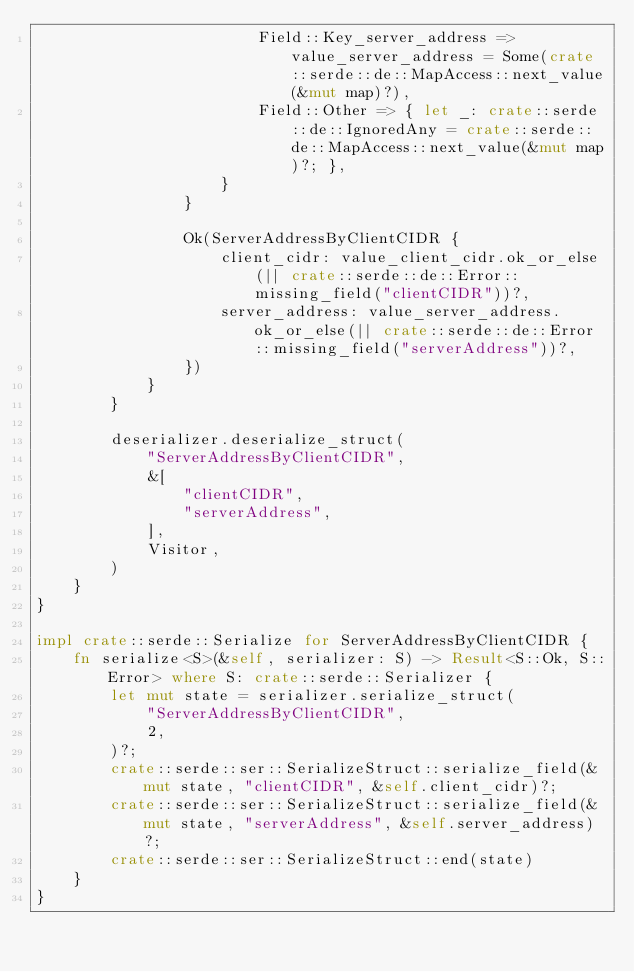Convert code to text. <code><loc_0><loc_0><loc_500><loc_500><_Rust_>                        Field::Key_server_address => value_server_address = Some(crate::serde::de::MapAccess::next_value(&mut map)?),
                        Field::Other => { let _: crate::serde::de::IgnoredAny = crate::serde::de::MapAccess::next_value(&mut map)?; },
                    }
                }

                Ok(ServerAddressByClientCIDR {
                    client_cidr: value_client_cidr.ok_or_else(|| crate::serde::de::Error::missing_field("clientCIDR"))?,
                    server_address: value_server_address.ok_or_else(|| crate::serde::de::Error::missing_field("serverAddress"))?,
                })
            }
        }

        deserializer.deserialize_struct(
            "ServerAddressByClientCIDR",
            &[
                "clientCIDR",
                "serverAddress",
            ],
            Visitor,
        )
    }
}

impl crate::serde::Serialize for ServerAddressByClientCIDR {
    fn serialize<S>(&self, serializer: S) -> Result<S::Ok, S::Error> where S: crate::serde::Serializer {
        let mut state = serializer.serialize_struct(
            "ServerAddressByClientCIDR",
            2,
        )?;
        crate::serde::ser::SerializeStruct::serialize_field(&mut state, "clientCIDR", &self.client_cidr)?;
        crate::serde::ser::SerializeStruct::serialize_field(&mut state, "serverAddress", &self.server_address)?;
        crate::serde::ser::SerializeStruct::end(state)
    }
}
</code> 